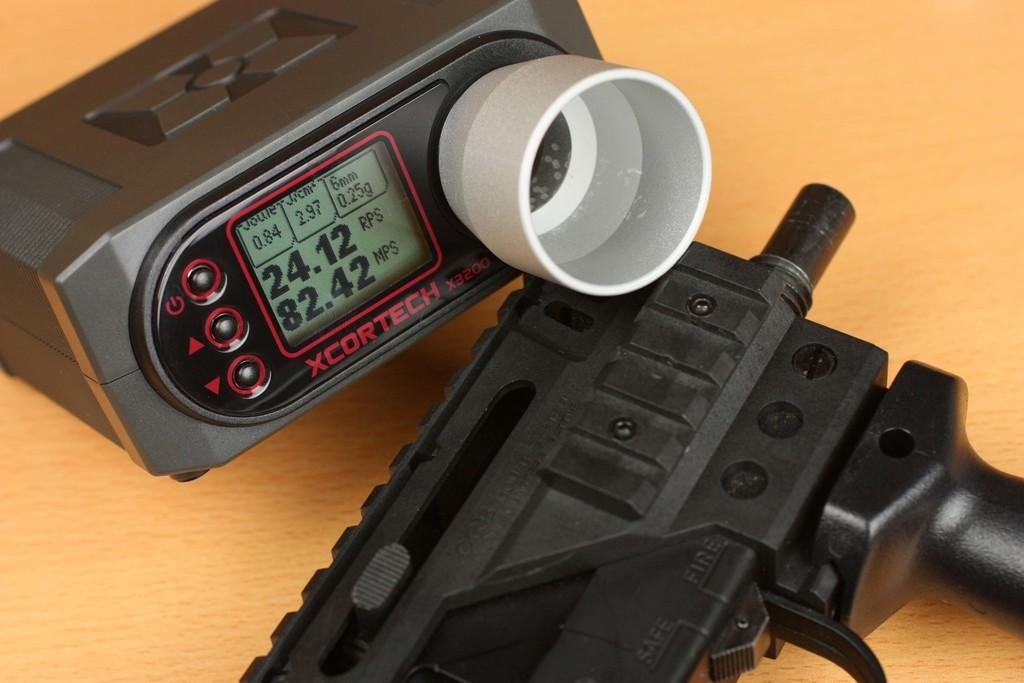Describe this image in one or two sentences. In this image I can see the cream colored surface and on it I can see a black colored object. I can see a white and black colored gadget which has a digital display. 